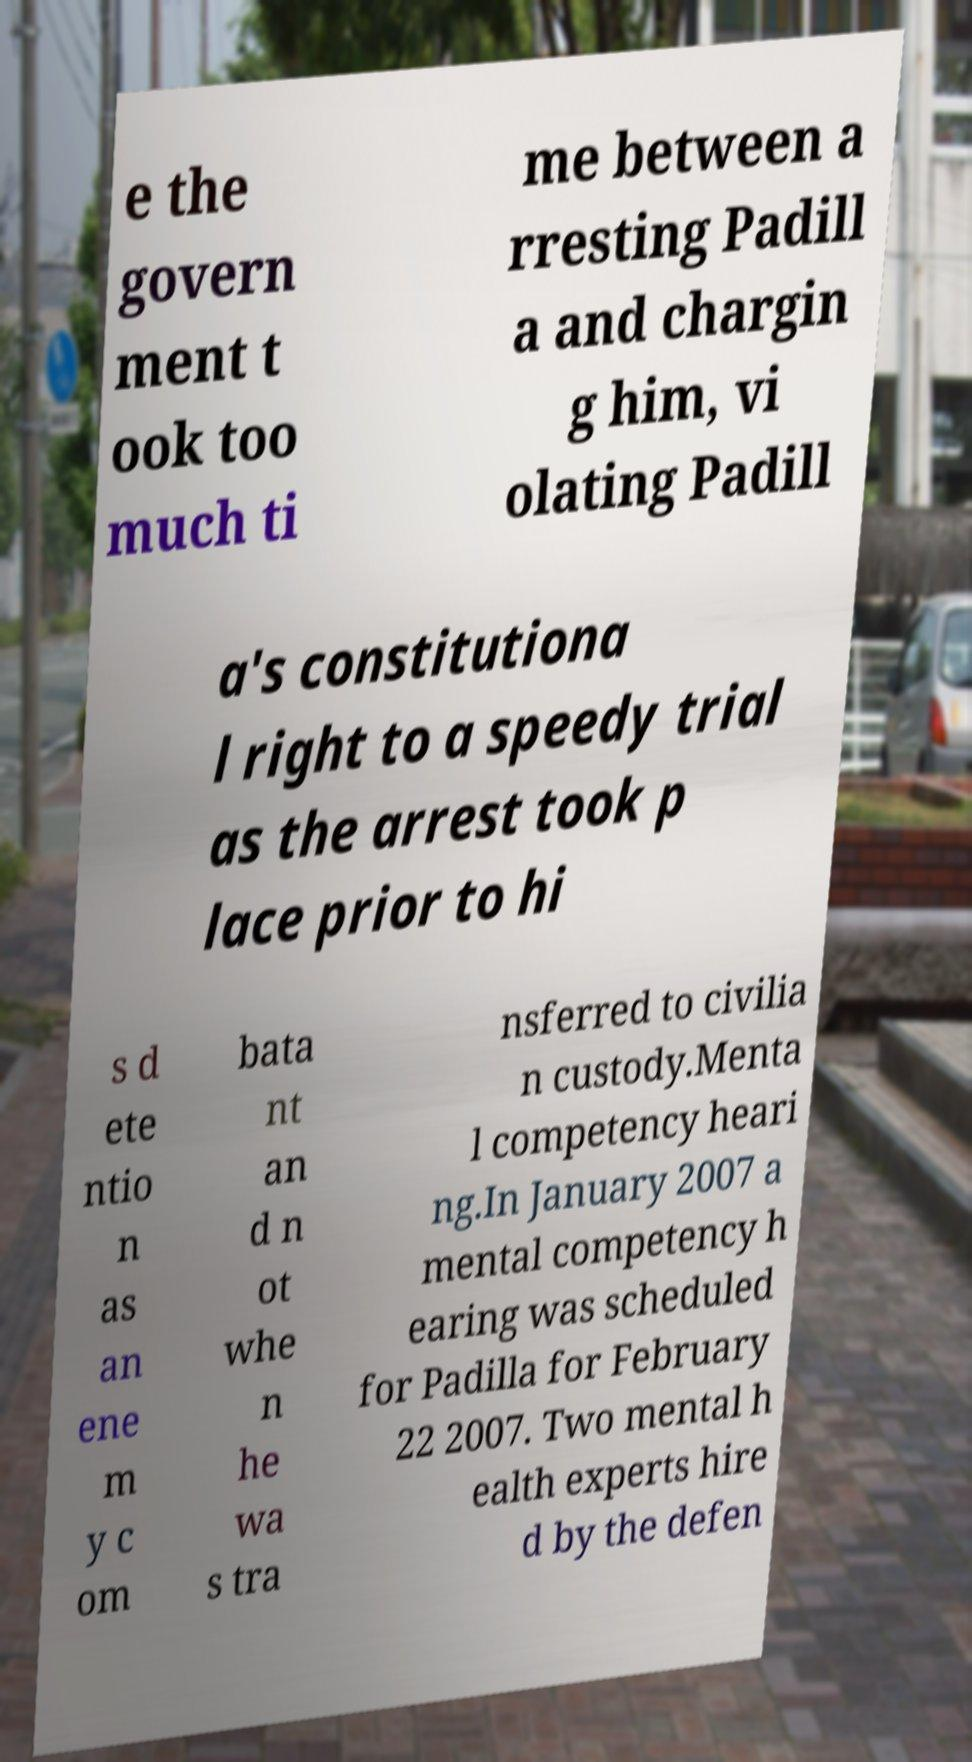Can you accurately transcribe the text from the provided image for me? e the govern ment t ook too much ti me between a rresting Padill a and chargin g him, vi olating Padill a's constitutiona l right to a speedy trial as the arrest took p lace prior to hi s d ete ntio n as an ene m y c om bata nt an d n ot whe n he wa s tra nsferred to civilia n custody.Menta l competency heari ng.In January 2007 a mental competency h earing was scheduled for Padilla for February 22 2007. Two mental h ealth experts hire d by the defen 